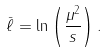<formula> <loc_0><loc_0><loc_500><loc_500>\bar { \ell } = \ln \left ( \frac { \mu ^ { 2 } } { s } \right ) .</formula> 